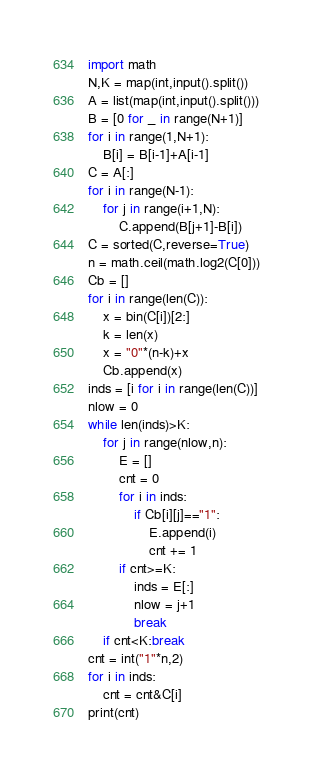Convert code to text. <code><loc_0><loc_0><loc_500><loc_500><_Python_>import math
N,K = map(int,input().split())
A = list(map(int,input().split()))
B = [0 for _ in range(N+1)]
for i in range(1,N+1):
    B[i] = B[i-1]+A[i-1]
C = A[:]
for i in range(N-1):
    for j in range(i+1,N):
        C.append(B[j+1]-B[i])
C = sorted(C,reverse=True)
n = math.ceil(math.log2(C[0]))
Cb = []
for i in range(len(C)):
    x = bin(C[i])[2:]
    k = len(x)
    x = "0"*(n-k)+x
    Cb.append(x)
inds = [i for i in range(len(C))]
nlow = 0
while len(inds)>K:
    for j in range(nlow,n):
        E = []
        cnt = 0
        for i in inds:
            if Cb[i][j]=="1":
                E.append(i)
                cnt += 1
        if cnt>=K:
            inds = E[:]
            nlow = j+1
            break
    if cnt<K:break
cnt = int("1"*n,2)
for i in inds: 
    cnt = cnt&C[i]
print(cnt)</code> 